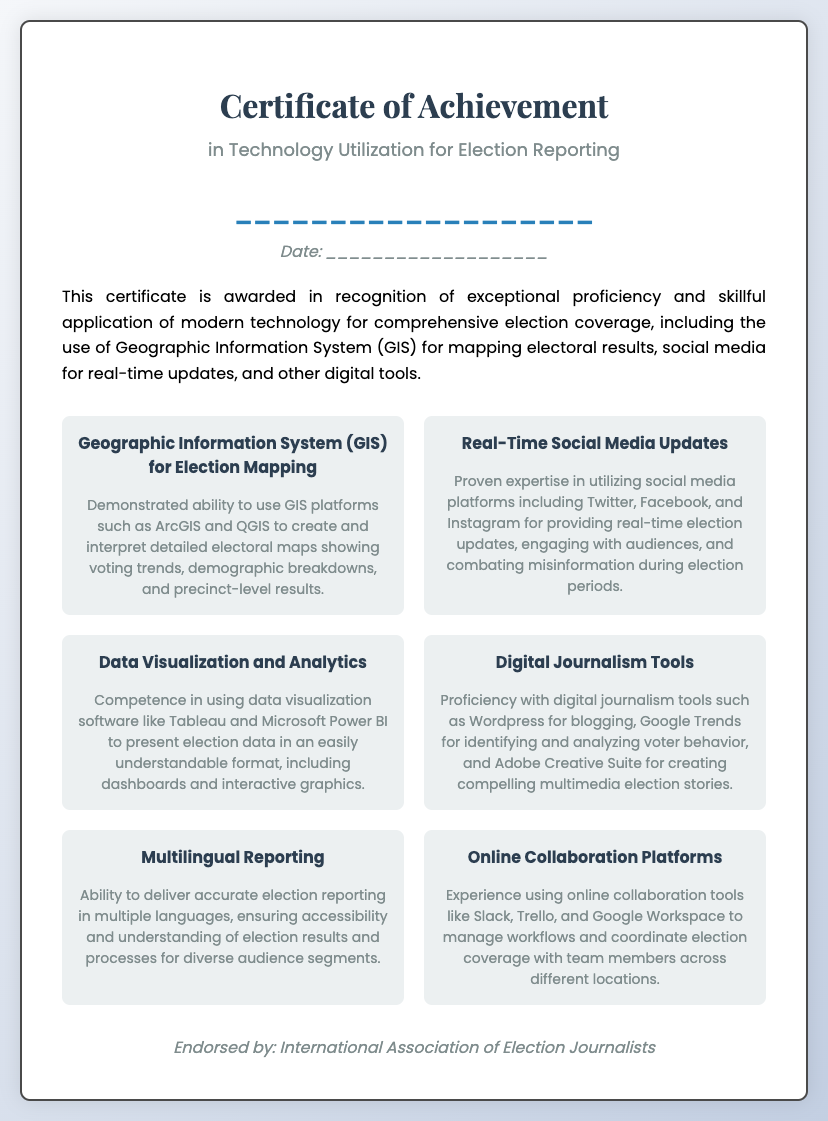What is the title of the certificate? The title of the certificate is located at the top of the document, indicating it is related to technology utilization in elections.
Answer: Certificate of Achievement in Technology Utilization for Election Reporting Who is the certificate awarded to? The recipient's name is indicated as a placeholder in the document, demonstrating the certificate's personalization aspect.
Answer: ___________________ What is the date of the certificate? The date appears as a placeholder in the document, representing when the certificate was awarded.
Answer: ___________________ What organization endorsed the certificate? The endorsement is found at the bottom of the document and highlights the authority behind the certificate.
Answer: International Association of Election Journalists Name one skill associated with GIS for Election Mapping. One skill mentioned pertains to the use of specific GIS platforms for creating electoral maps, showcasing technical expertise.
Answer: ArcGIS and QGIS Which social media platforms are mentioned for real-time updates? The document lists specific social media platforms that are utilized for election updates, highlighting their relevance in modern reporting.
Answer: Twitter, Facebook, and Instagram What does the Digital Journalism Tools skill include? This skill elaborates on digital tools used for creating multimedia election stories, emphasizing the blend of technology and journalism.
Answer: Wordpress How many skills are listed in the certificate? The document provides a detailed list of skills, each reflecting a different area of expertise in election reporting technology.
Answer: Six What is one tool listed for data visualization? The certificate names a specific software that is used for visualizing data effectively in an election context.
Answer: Tableau What is the focus of the certificate? The certificate emphasizes the application of technology in a specific field, which is essential for understanding its purpose.
Answer: Technology Utilization for Election Reporting 